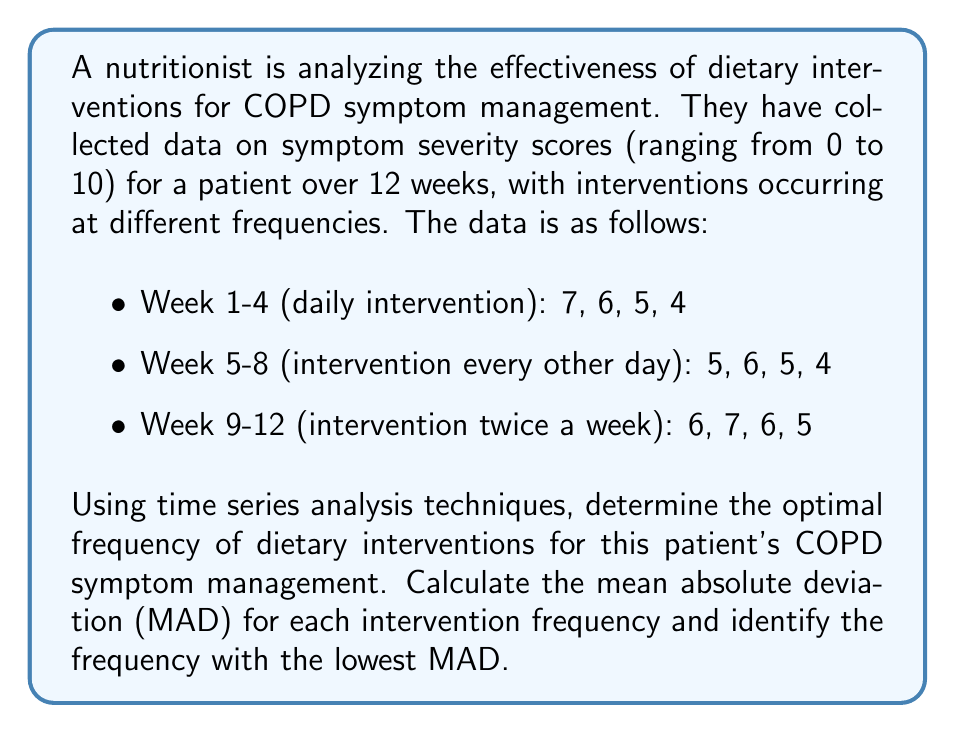Provide a solution to this math problem. To determine the optimal frequency of dietary interventions, we'll calculate the Mean Absolute Deviation (MAD) for each intervention frequency. The MAD measures the average distance between each data point and the mean, providing a measure of variability in the symptom severity scores.

Step 1: Calculate the mean for each intervention frequency.

Daily intervention (Week 1-4):
$\mu_1 = \frac{7 + 6 + 5 + 4}{4} = 5.5$

Every other day (Week 5-8):
$\mu_2 = \frac{5 + 6 + 5 + 4}{4} = 5$

Twice a week (Week 9-12):
$\mu_3 = \frac{6 + 7 + 6 + 5}{4} = 6$

Step 2: Calculate the absolute deviations from the mean for each data point.

Daily intervention:
$|7 - 5.5| = 1.5$, $|6 - 5.5| = 0.5$, $|5 - 5.5| = 0.5$, $|4 - 5.5| = 1.5$

Every other day:
$|5 - 5| = 0$, $|6 - 5| = 1$, $|5 - 5| = 0$, $|4 - 5| = 1$

Twice a week:
$|6 - 6| = 0$, $|7 - 6| = 1$, $|6 - 6| = 0$, $|5 - 6| = 1$

Step 3: Calculate the MAD for each intervention frequency.

MAD for daily intervention:
$MAD_1 = \frac{1.5 + 0.5 + 0.5 + 1.5}{4} = 1$

MAD for every other day:
$MAD_2 = \frac{0 + 1 + 0 + 1}{4} = 0.5$

MAD for twice a week:
$MAD_3 = \frac{0 + 1 + 0 + 1}{4} = 0.5$

Step 4: Identify the frequency with the lowest MAD.

The lowest MAD is 0.5, which corresponds to both the "every other day" and "twice a week" frequencies. However, since the mean symptom severity score for "every other day" (5) is lower than that for "twice a week" (6), we can conclude that the optimal frequency is every other day.
Answer: The optimal frequency of dietary interventions for this patient's COPD symptom management is every other day, with a Mean Absolute Deviation (MAD) of 0.5 and the lowest mean symptom severity score of 5. 